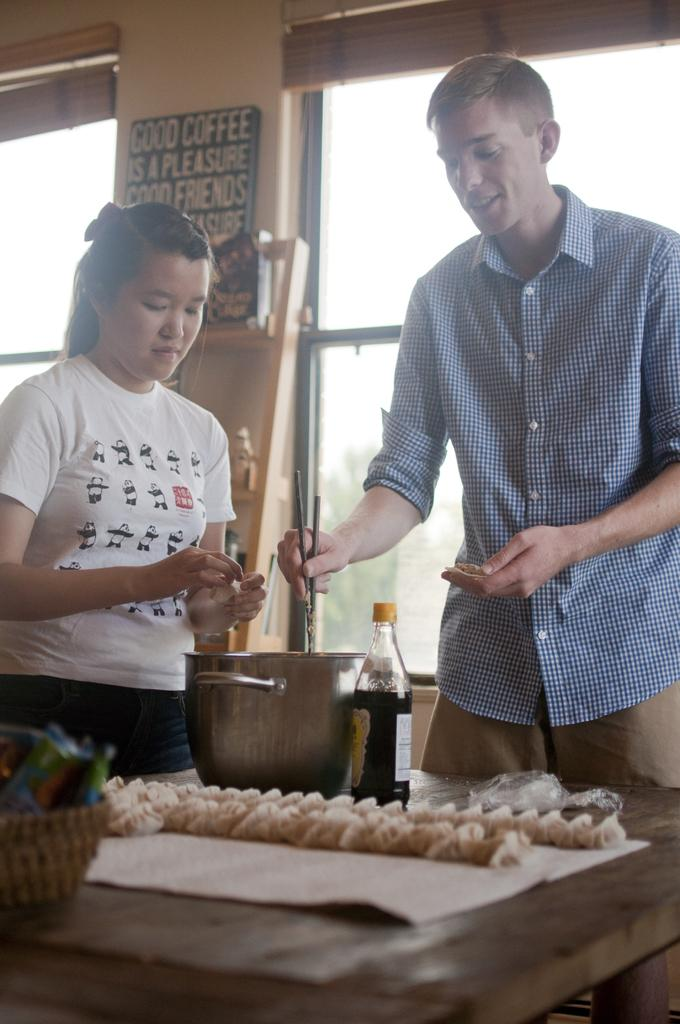How many people are in the image? There is a woman and a man in the image. What is the man doing in the image? The man is standing and doing some work in a bowl. What can be seen on the table in the image? There is food on a table in the image. What is visible in the background of the image? There is a board, a wall, and a window in the background of the image. What type of nose can be seen on the goat in the image? There is no goat present in the image, so it is not possible to determine the type of nose on a goat. What size shoe is the woman wearing in the image? There is no information about the woman's shoes in the image, so it is not possible to determine the size of her shoe. 